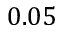Convert formula to latex. <formula><loc_0><loc_0><loc_500><loc_500>0 . 0 5</formula> 